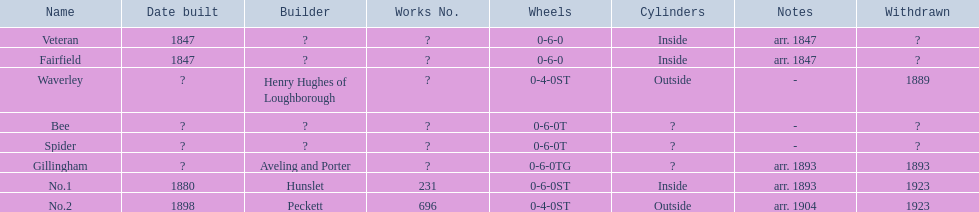Which have confirmed construction dates? Veteran, Fairfield, No.1, No.2. What else was constructed in 1847? Veteran. 